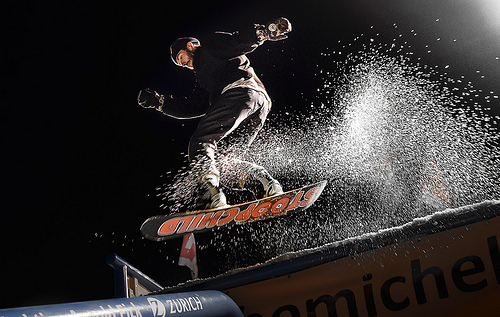<image>
Is the snow behind the sign? No. The snow is not behind the sign. From this viewpoint, the snow appears to be positioned elsewhere in the scene. 